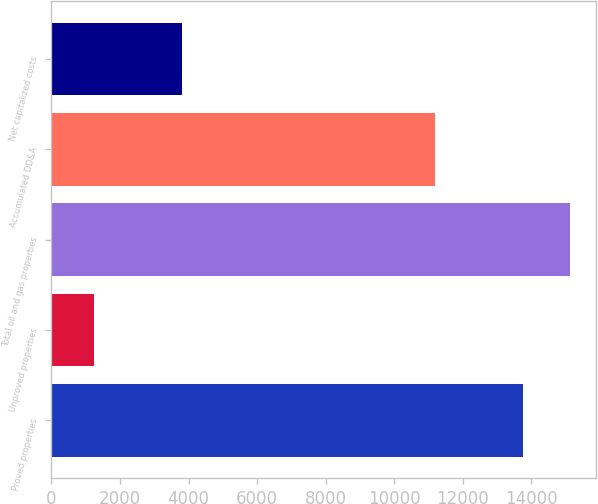<chart> <loc_0><loc_0><loc_500><loc_500><bar_chart><fcel>Proved properties<fcel>Unproved properties<fcel>Total oil and gas properties<fcel>Accumulated DD&A<fcel>Net capitalized costs<nl><fcel>13747<fcel>1232<fcel>15121.7<fcel>11185<fcel>3794<nl></chart> 